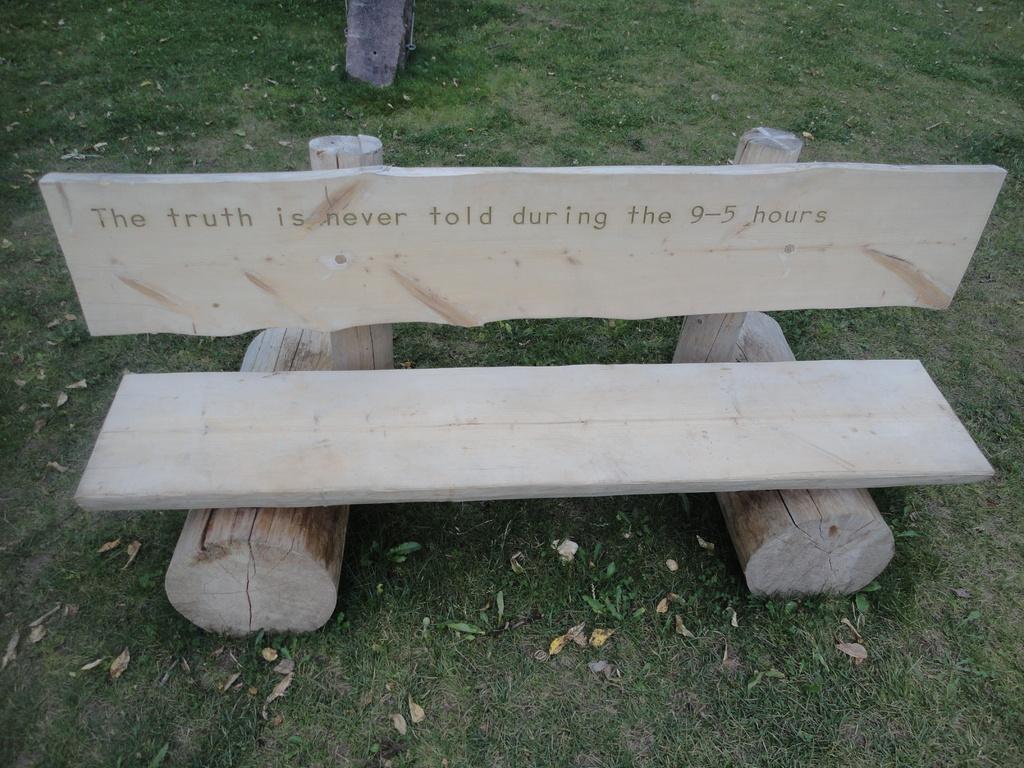How would you summarize this image in a sentence or two? In the picture there are dry leaves, grass and wooden bench. At the top there is a trunk of a tree. 